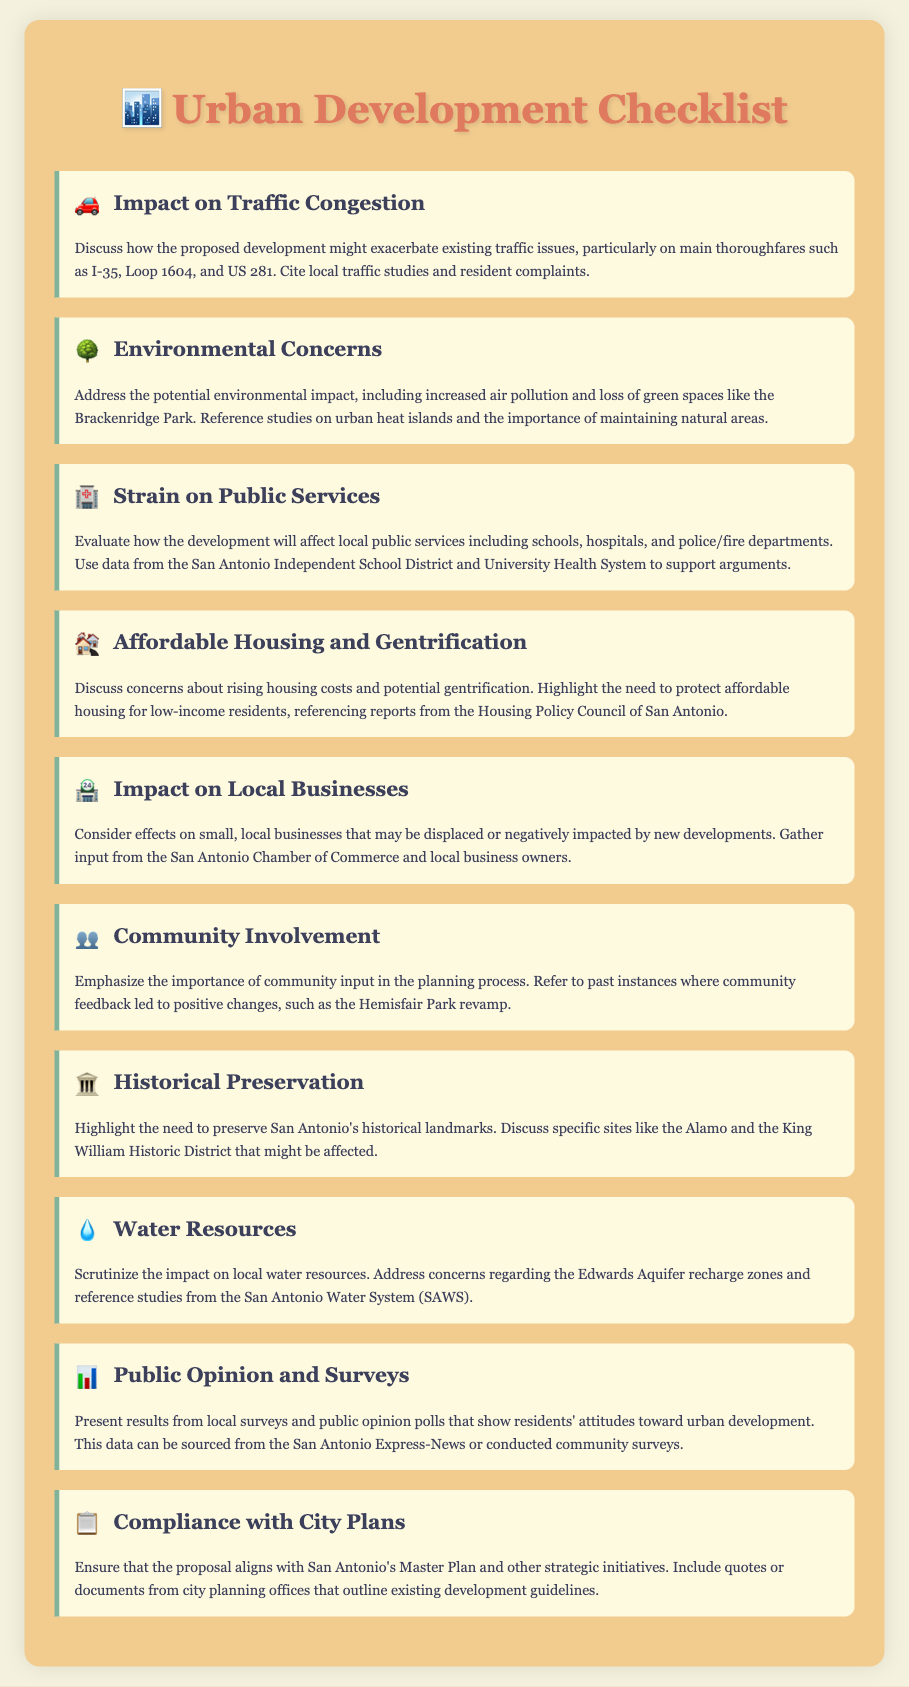What is the first item on the checklist? The first item on the checklist is the section discussing the impact on traffic congestion.
Answer: Impact on Traffic Congestion How many items are in the checklist? The document contains a total of ten checklist items.
Answer: Ten What environmental concern is mentioned in the checklist? The checklist mentions increased air pollution and loss of green spaces.
Answer: Increased air pollution and loss of green spaces Which local system should be referenced for evaluating the strain on public services? The San Antonio Independent School District is mentioned for discussing public service strain.
Answer: San Antonio Independent School District What topic does the checklist highlight about community input? The checklist emphasizes the importance of community involvement in the planning process.
Answer: Importance of community involvement What specific historical site is referenced for preservation? The Alamo is specifically mentioned as a historical site needing preservation.
Answer: The Alamo What is a primary concern regarding housing mentioned in the checklist? The checklist raises concerns about rising housing costs and potential gentrification.
Answer: Rising housing costs and potential gentrification Which water resource concern is highlighted in the document? The document highlights the impact on local water resources, particularly the Edwards Aquifer recharge zones.
Answer: Edwards Aquifer recharge zones What organization should be contacted for input on local businesses? Input from the San Antonio Chamber of Commerce is suggested regarding local businesses.
Answer: San Antonio Chamber of Commerce 